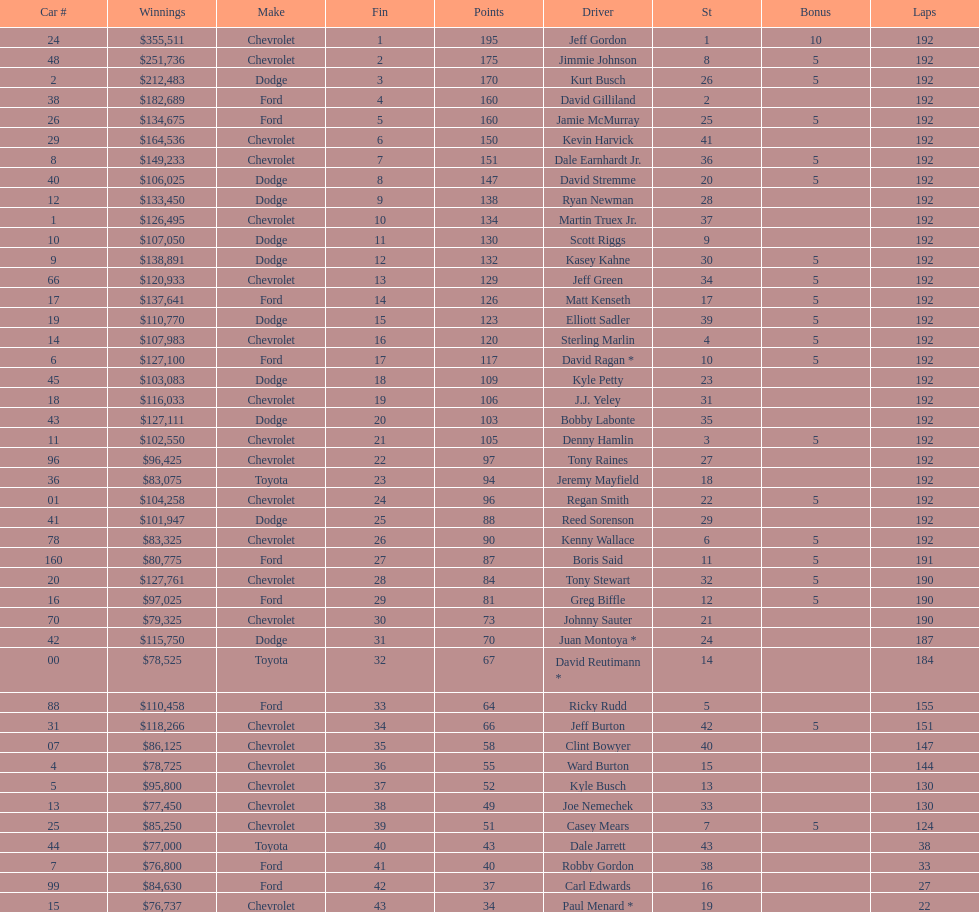I'm looking to parse the entire table for insights. Could you assist me with that? {'header': ['Car #', 'Winnings', 'Make', 'Fin', 'Points', 'Driver', 'St', 'Bonus', 'Laps'], 'rows': [['24', '$355,511', 'Chevrolet', '1', '195', 'Jeff Gordon', '1', '10', '192'], ['48', '$251,736', 'Chevrolet', '2', '175', 'Jimmie Johnson', '8', '5', '192'], ['2', '$212,483', 'Dodge', '3', '170', 'Kurt Busch', '26', '5', '192'], ['38', '$182,689', 'Ford', '4', '160', 'David Gilliland', '2', '', '192'], ['26', '$134,675', 'Ford', '5', '160', 'Jamie McMurray', '25', '5', '192'], ['29', '$164,536', 'Chevrolet', '6', '150', 'Kevin Harvick', '41', '', '192'], ['8', '$149,233', 'Chevrolet', '7', '151', 'Dale Earnhardt Jr.', '36', '5', '192'], ['40', '$106,025', 'Dodge', '8', '147', 'David Stremme', '20', '5', '192'], ['12', '$133,450', 'Dodge', '9', '138', 'Ryan Newman', '28', '', '192'], ['1', '$126,495', 'Chevrolet', '10', '134', 'Martin Truex Jr.', '37', '', '192'], ['10', '$107,050', 'Dodge', '11', '130', 'Scott Riggs', '9', '', '192'], ['9', '$138,891', 'Dodge', '12', '132', 'Kasey Kahne', '30', '5', '192'], ['66', '$120,933', 'Chevrolet', '13', '129', 'Jeff Green', '34', '5', '192'], ['17', '$137,641', 'Ford', '14', '126', 'Matt Kenseth', '17', '5', '192'], ['19', '$110,770', 'Dodge', '15', '123', 'Elliott Sadler', '39', '5', '192'], ['14', '$107,983', 'Chevrolet', '16', '120', 'Sterling Marlin', '4', '5', '192'], ['6', '$127,100', 'Ford', '17', '117', 'David Ragan *', '10', '5', '192'], ['45', '$103,083', 'Dodge', '18', '109', 'Kyle Petty', '23', '', '192'], ['18', '$116,033', 'Chevrolet', '19', '106', 'J.J. Yeley', '31', '', '192'], ['43', '$127,111', 'Dodge', '20', '103', 'Bobby Labonte', '35', '', '192'], ['11', '$102,550', 'Chevrolet', '21', '105', 'Denny Hamlin', '3', '5', '192'], ['96', '$96,425', 'Chevrolet', '22', '97', 'Tony Raines', '27', '', '192'], ['36', '$83,075', 'Toyota', '23', '94', 'Jeremy Mayfield', '18', '', '192'], ['01', '$104,258', 'Chevrolet', '24', '96', 'Regan Smith', '22', '5', '192'], ['41', '$101,947', 'Dodge', '25', '88', 'Reed Sorenson', '29', '', '192'], ['78', '$83,325', 'Chevrolet', '26', '90', 'Kenny Wallace', '6', '5', '192'], ['160', '$80,775', 'Ford', '27', '87', 'Boris Said', '11', '5', '191'], ['20', '$127,761', 'Chevrolet', '28', '84', 'Tony Stewart', '32', '5', '190'], ['16', '$97,025', 'Ford', '29', '81', 'Greg Biffle', '12', '5', '190'], ['70', '$79,325', 'Chevrolet', '30', '73', 'Johnny Sauter', '21', '', '190'], ['42', '$115,750', 'Dodge', '31', '70', 'Juan Montoya *', '24', '', '187'], ['00', '$78,525', 'Toyota', '32', '67', 'David Reutimann *', '14', '', '184'], ['88', '$110,458', 'Ford', '33', '64', 'Ricky Rudd', '5', '', '155'], ['31', '$118,266', 'Chevrolet', '34', '66', 'Jeff Burton', '42', '5', '151'], ['07', '$86,125', 'Chevrolet', '35', '58', 'Clint Bowyer', '40', '', '147'], ['4', '$78,725', 'Chevrolet', '36', '55', 'Ward Burton', '15', '', '144'], ['5', '$95,800', 'Chevrolet', '37', '52', 'Kyle Busch', '13', '', '130'], ['13', '$77,450', 'Chevrolet', '38', '49', 'Joe Nemechek', '33', '', '130'], ['25', '$85,250', 'Chevrolet', '39', '51', 'Casey Mears', '7', '5', '124'], ['44', '$77,000', 'Toyota', '40', '43', 'Dale Jarrett', '43', '', '38'], ['7', '$76,800', 'Ford', '41', '40', 'Robby Gordon', '38', '', '33'], ['99', '$84,630', 'Ford', '42', '37', 'Carl Edwards', '16', '', '27'], ['15', '$76,737', 'Chevrolet', '43', '34', 'Paul Menard *', '19', '', '22']]} How many drivers earned 5 bonus each in the race? 19. 